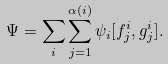Convert formula to latex. <formula><loc_0><loc_0><loc_500><loc_500>\Psi = \sum _ { i } \sum _ { j = 1 } ^ { \alpha ( i ) } \psi _ { i } [ f _ { j } ^ { i } , g _ { j } ^ { i } ] .</formula> 